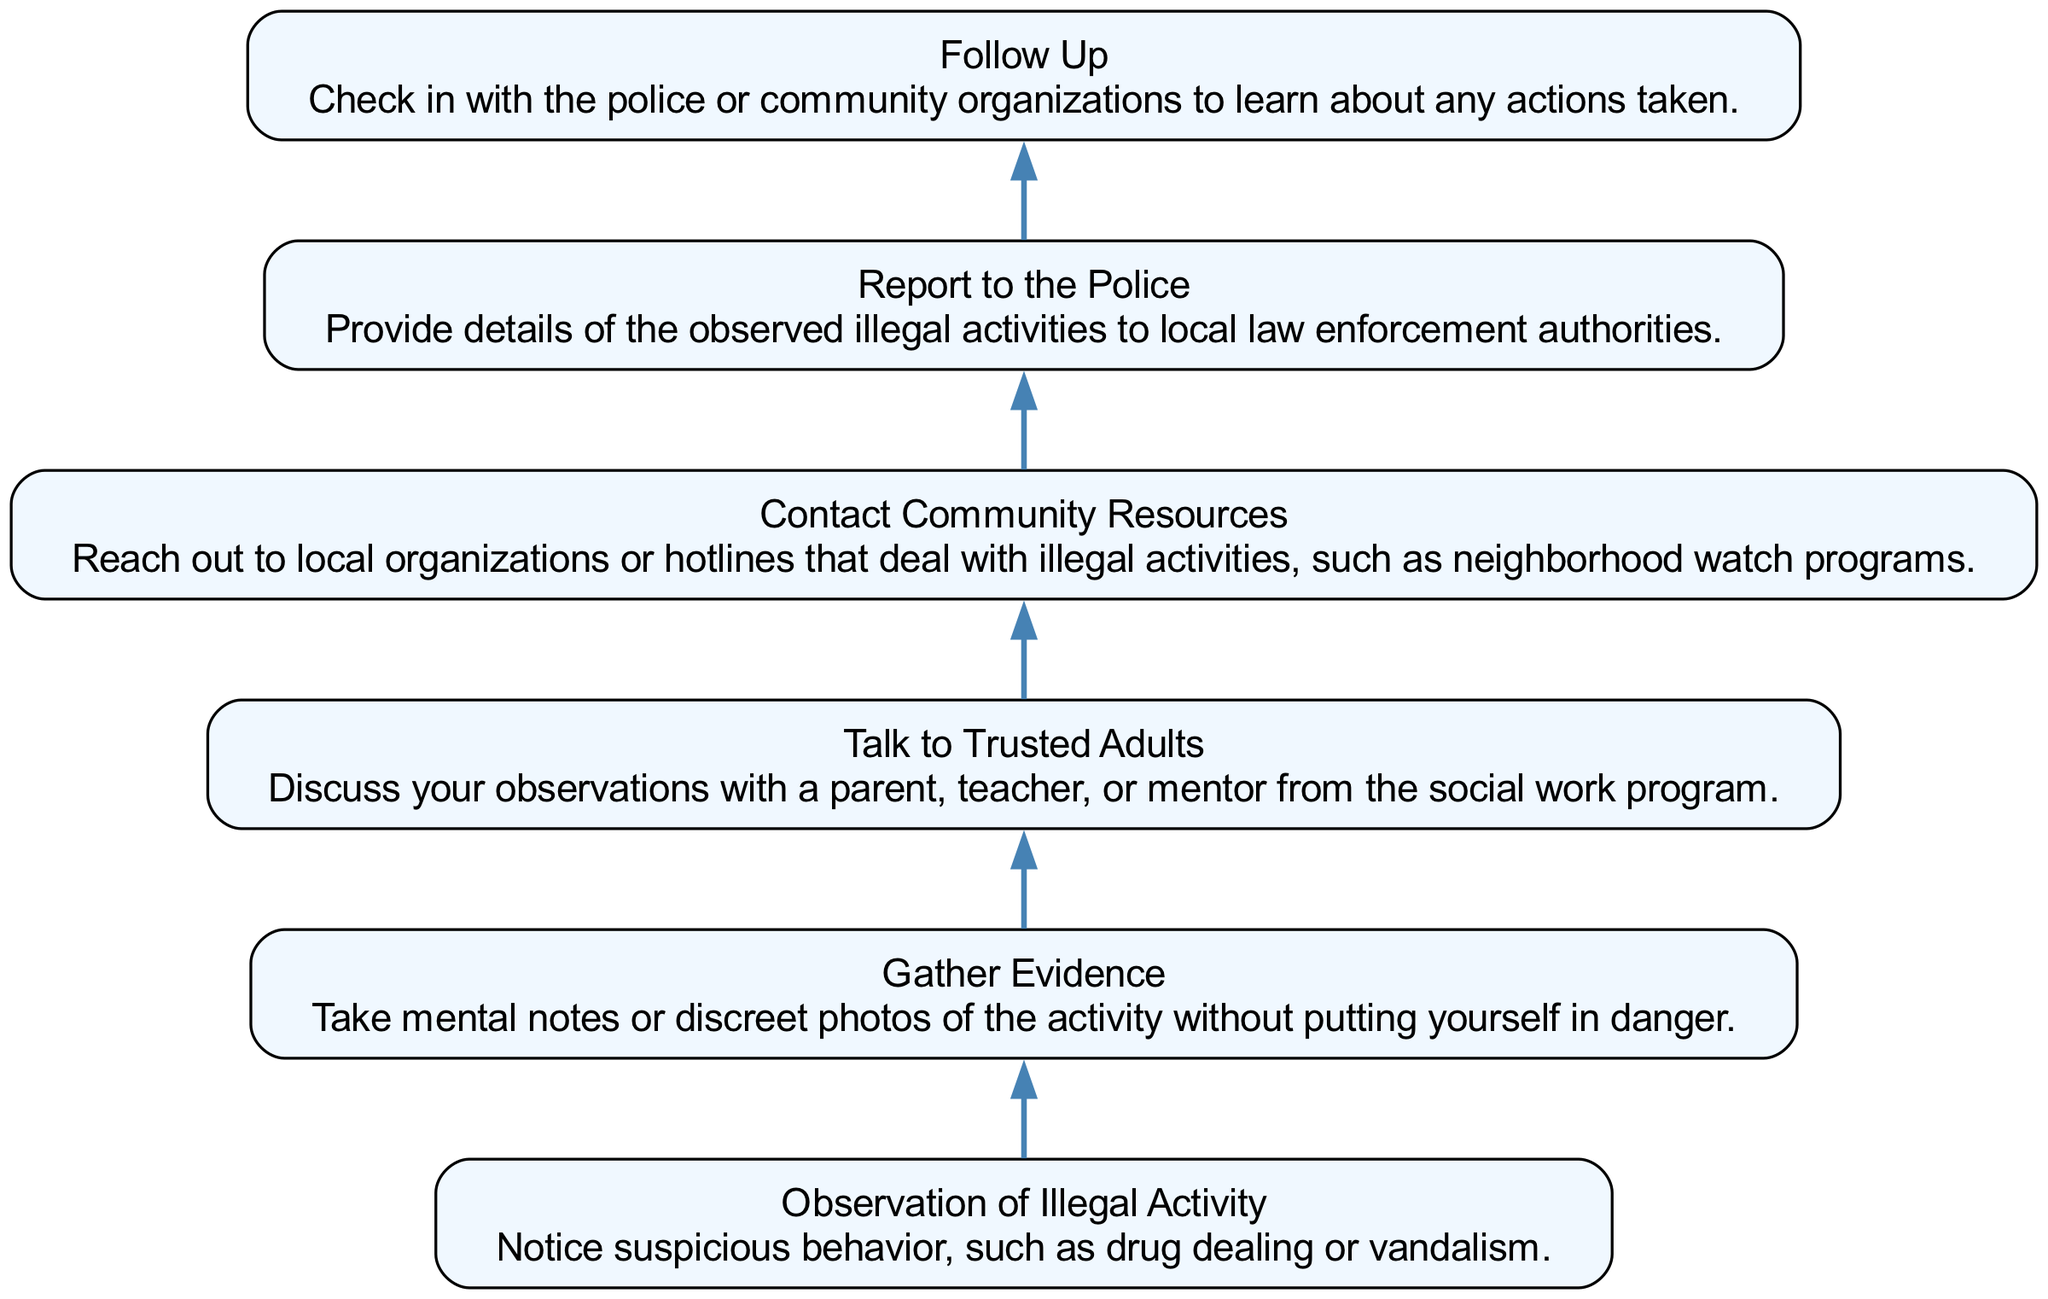What is the first step in the diagram? The diagram starts with the first node labeled "Observation of Illegal Activity." This indicates that noticing suspicious behavior is the initial action one should take before proceeding to any other steps.
Answer: Observation of Illegal Activity How many total nodes are present in the diagram? By counting each labeled node, we find there are six distinct nodes in the flowchart representing each step in the reporting process.
Answer: 6 What do you do after gathering evidence? After "Gather Evidence," the next step is to "Talk to Trusted Adults." This indicates that gathering information should be followed by discussing it with someone you trust for guidance.
Answer: Talk to Trusted Adults What is the last action in the flow chart? The final step indicated in the diagram is "Follow Up," which emphasizes the importance of checking back to see what actions were taken regarding the reported illegal activities.
Answer: Follow Up What is the relationship between "Talk to Trusted Adults" and "Contact Community Resources"? "Talk to Trusted Adults" precedes "Contact Community Resources," indicating that discussing your observations with trusted individuals is an essential step before reaching out to organizations or hotlines for assistance.
Answer: Precedes 